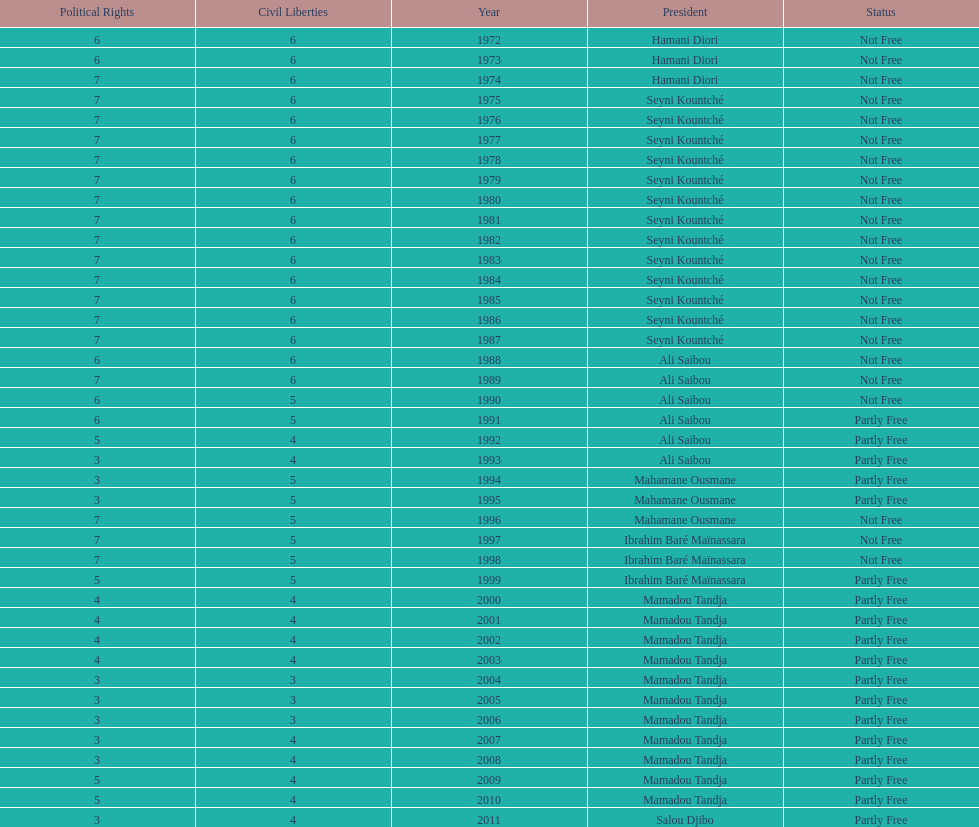Who is the next president listed after hamani diori in the year 1974? Seyni Kountché. 